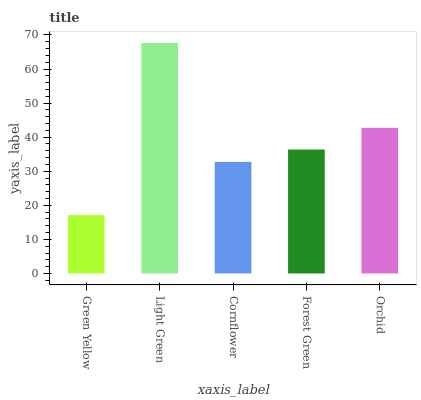Is Cornflower the minimum?
Answer yes or no. No. Is Cornflower the maximum?
Answer yes or no. No. Is Light Green greater than Cornflower?
Answer yes or no. Yes. Is Cornflower less than Light Green?
Answer yes or no. Yes. Is Cornflower greater than Light Green?
Answer yes or no. No. Is Light Green less than Cornflower?
Answer yes or no. No. Is Forest Green the high median?
Answer yes or no. Yes. Is Forest Green the low median?
Answer yes or no. Yes. Is Green Yellow the high median?
Answer yes or no. No. Is Orchid the low median?
Answer yes or no. No. 